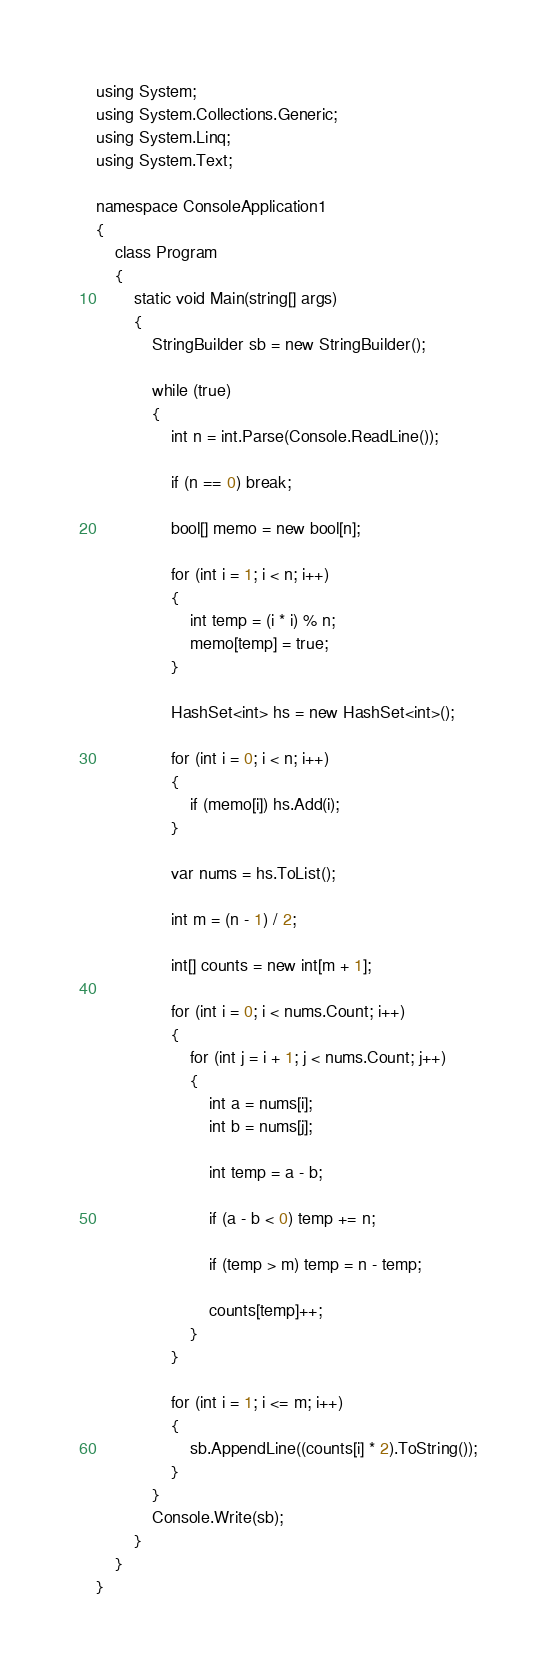Convert code to text. <code><loc_0><loc_0><loc_500><loc_500><_C#_>using System;
using System.Collections.Generic;
using System.Linq;
using System.Text;

namespace ConsoleApplication1
{
    class Program
    {
        static void Main(string[] args)
        {
            StringBuilder sb = new StringBuilder();

            while (true)
            {
                int n = int.Parse(Console.ReadLine());

                if (n == 0) break;

                bool[] memo = new bool[n];

                for (int i = 1; i < n; i++)
                {
                    int temp = (i * i) % n;
                    memo[temp] = true;
                }

                HashSet<int> hs = new HashSet<int>();

                for (int i = 0; i < n; i++)
                {
                    if (memo[i]) hs.Add(i);
                }

                var nums = hs.ToList();

                int m = (n - 1) / 2;

                int[] counts = new int[m + 1];

                for (int i = 0; i < nums.Count; i++)
                {
                    for (int j = i + 1; j < nums.Count; j++)
                    {
                        int a = nums[i];
                        int b = nums[j];

                        int temp = a - b;

                        if (a - b < 0) temp += n;

                        if (temp > m) temp = n - temp;

                        counts[temp]++;
                    }
                }

                for (int i = 1; i <= m; i++)
                {
                    sb.AppendLine((counts[i] * 2).ToString());
                }
            }
            Console.Write(sb);
        }
    }
}</code> 